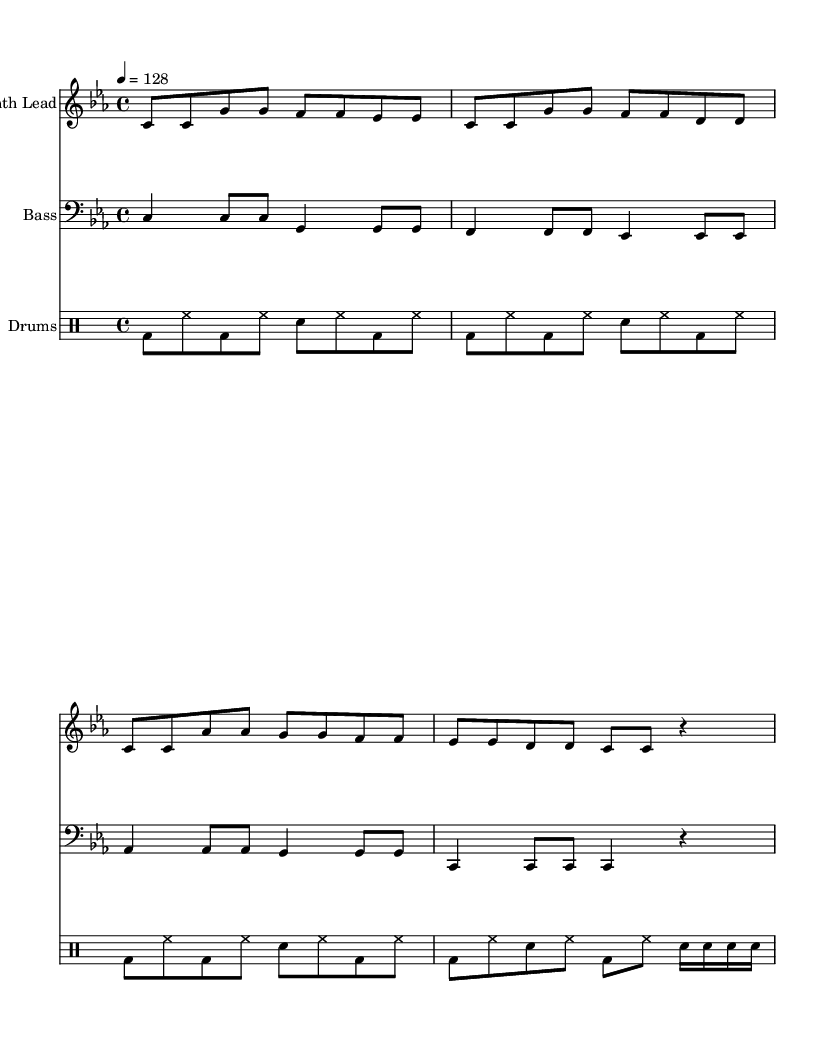What is the key signature of this music? The key signature is C minor, which has three flats (B flat, E flat, and A flat). This is indicated at the beginning of the staff with the flat symbols.
Answer: C minor What is the time signature of this piece? The time signature is 4/4, which means there are four beats in each measure and the quarter note gets one beat. This is marked at the beginning of the score.
Answer: 4/4 What is the tempo marking in this score? The tempo marking indicates that the piece should be played at a speed of 128 beats per minute, shown as '4 = 128' at the beginning of the music.
Answer: 128 How many measures are in the synth lead section? Counting the measures in the 'synthLead' section shows that there are four measures present. This can be determined by visual inspection of the staffs.
Answer: 4 What is the rhythmic pattern of the drums in the last measure? The last measure consists of a kick drum (bd) followed by a snare (sn) with additional sixteenth notes (sn), indicating a variation in rhythm typical for dance music. The specific combination of drum hits can be analyzed by looking at the drum staff.
Answer: kick and snare What instruments are featured in this score? The instrumental parts included are Synth Lead, Bass, and Drums. Each part is assigned to a separate staff, clearly labeled at the beginning of each section.
Answer: Synth Lead, Bass, Drums What defines the genre of this music piece? The genre is characterized by high-energy beats and synth leads with industrial influences, focusing on rhythm and driving bass lines typical of dance music. This can be inferred from the combination of synth patterns, bass lines, and drum beats.
Answer: Dance 